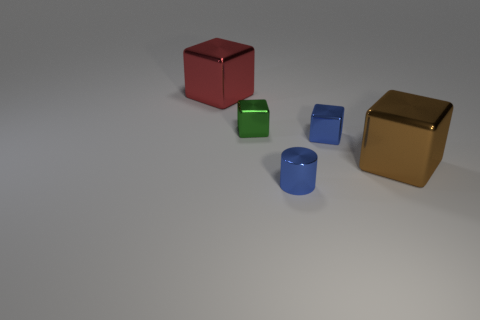Is the shape of the green object the same as the red object?
Offer a terse response. Yes. What color is the small cylinder that is the same material as the big red object?
Offer a very short reply. Blue. What number of objects are either blue shiny objects that are to the right of the metallic cylinder or tiny brown metal spheres?
Ensure brevity in your answer.  1. How big is the blue metallic thing in front of the brown object?
Ensure brevity in your answer.  Small. Is the size of the red thing the same as the cylinder that is in front of the red metal thing?
Ensure brevity in your answer.  No. What is the color of the tiny object behind the small blue object on the right side of the small cylinder?
Provide a succinct answer. Green. How many other things are the same color as the tiny cylinder?
Your answer should be very brief. 1. What is the size of the brown metallic block?
Provide a short and direct response. Large. Are there more small blue metal cubes behind the tiny blue metallic block than small blue shiny cylinders that are behind the metal cylinder?
Offer a very short reply. No. There is a large object in front of the small blue metal block; how many big brown objects are behind it?
Keep it short and to the point. 0. 